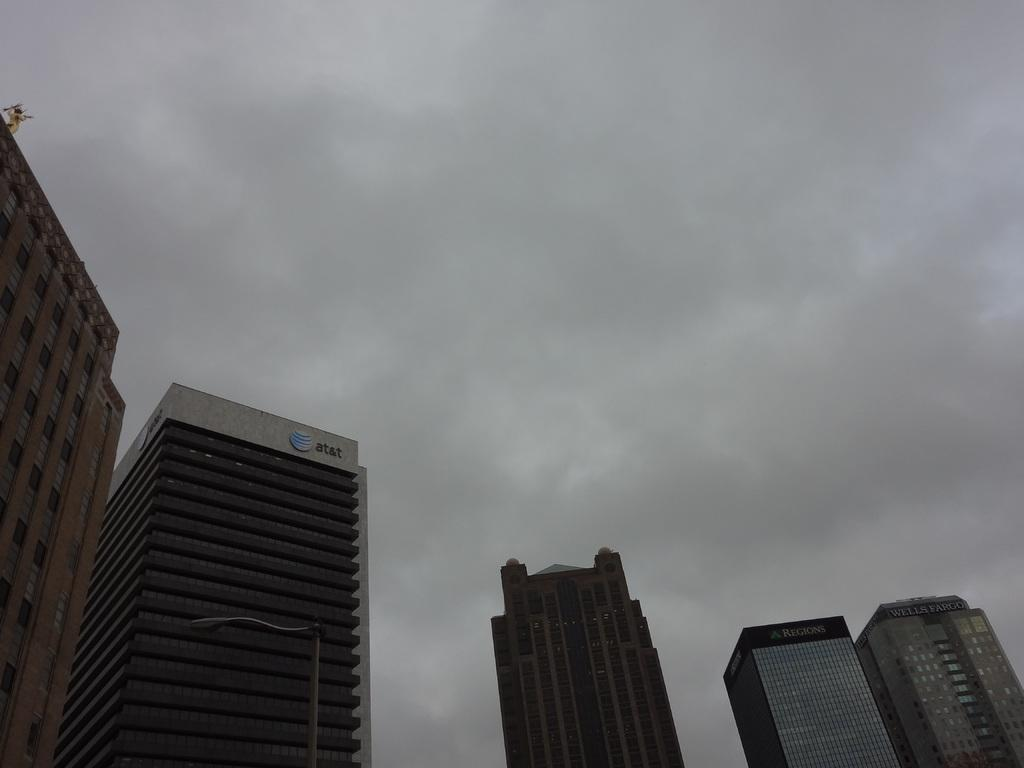What type of structures can be seen in the image? There are buildings in the image. What else can be seen besides the buildings? There is an electric pole in the image. What is visible in the background of the image? The sky is visible in the background of the image. How many hens are sitting on the chairs in the image? There are no hens or chairs present in the image. What type of stamp can be seen on the buildings in the image? There is no stamp visible on the buildings in the image. 